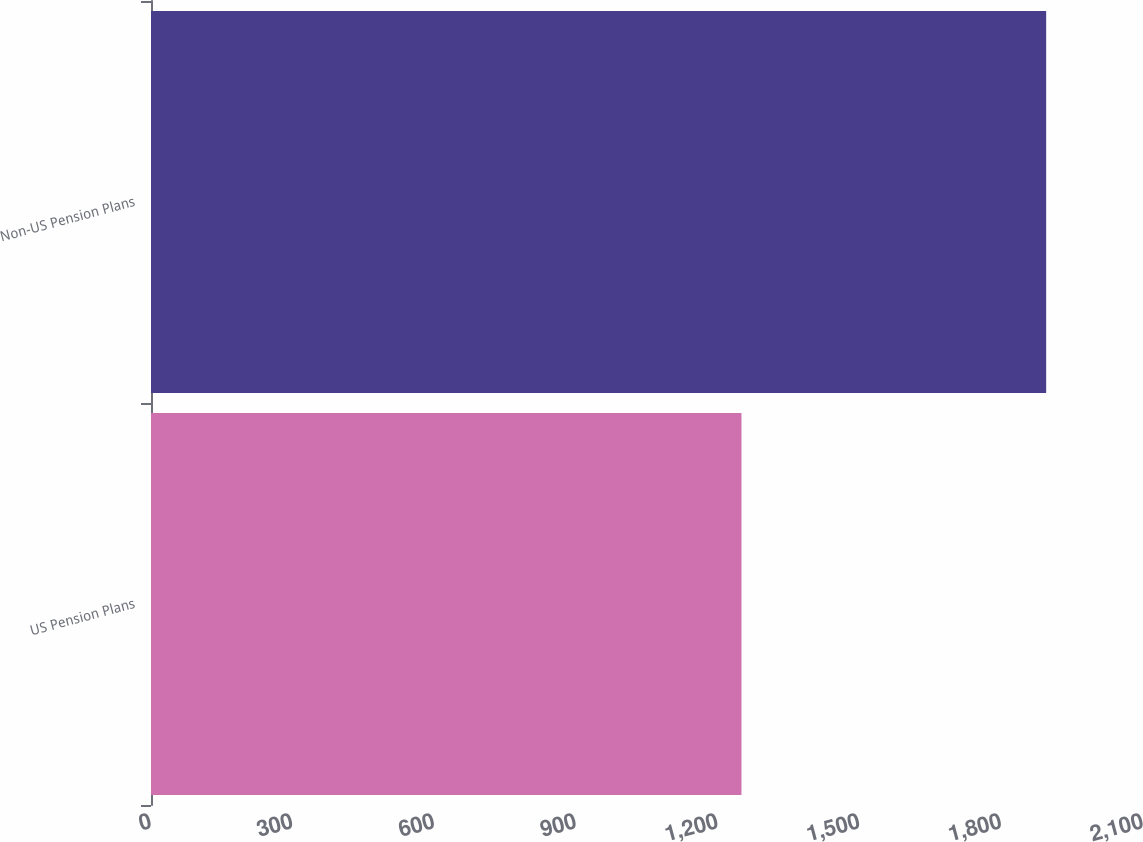Convert chart. <chart><loc_0><loc_0><loc_500><loc_500><bar_chart><fcel>US Pension Plans<fcel>Non-US Pension Plans<nl><fcel>1250<fcel>1895<nl></chart> 